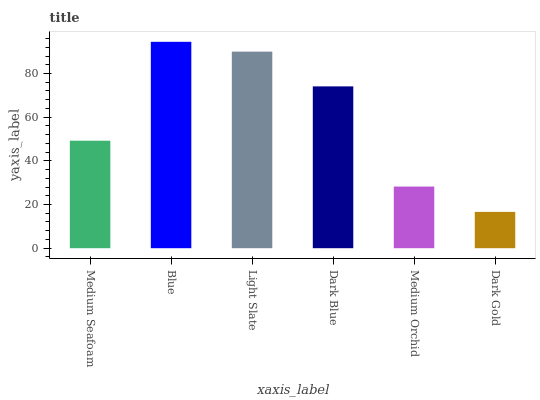Is Dark Gold the minimum?
Answer yes or no. Yes. Is Blue the maximum?
Answer yes or no. Yes. Is Light Slate the minimum?
Answer yes or no. No. Is Light Slate the maximum?
Answer yes or no. No. Is Blue greater than Light Slate?
Answer yes or no. Yes. Is Light Slate less than Blue?
Answer yes or no. Yes. Is Light Slate greater than Blue?
Answer yes or no. No. Is Blue less than Light Slate?
Answer yes or no. No. Is Dark Blue the high median?
Answer yes or no. Yes. Is Medium Seafoam the low median?
Answer yes or no. Yes. Is Medium Orchid the high median?
Answer yes or no. No. Is Dark Gold the low median?
Answer yes or no. No. 